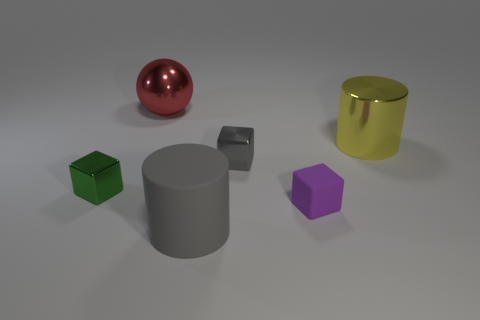Subtract all matte blocks. How many blocks are left? 2 Subtract all purple cubes. How many cubes are left? 2 Subtract all balls. How many objects are left? 5 Add 3 big things. How many objects exist? 9 Subtract all red blocks. How many yellow cylinders are left? 1 Subtract 0 purple cylinders. How many objects are left? 6 Subtract 1 cylinders. How many cylinders are left? 1 Subtract all gray cubes. Subtract all green cylinders. How many cubes are left? 2 Subtract all spheres. Subtract all large yellow things. How many objects are left? 4 Add 5 tiny green things. How many tiny green things are left? 6 